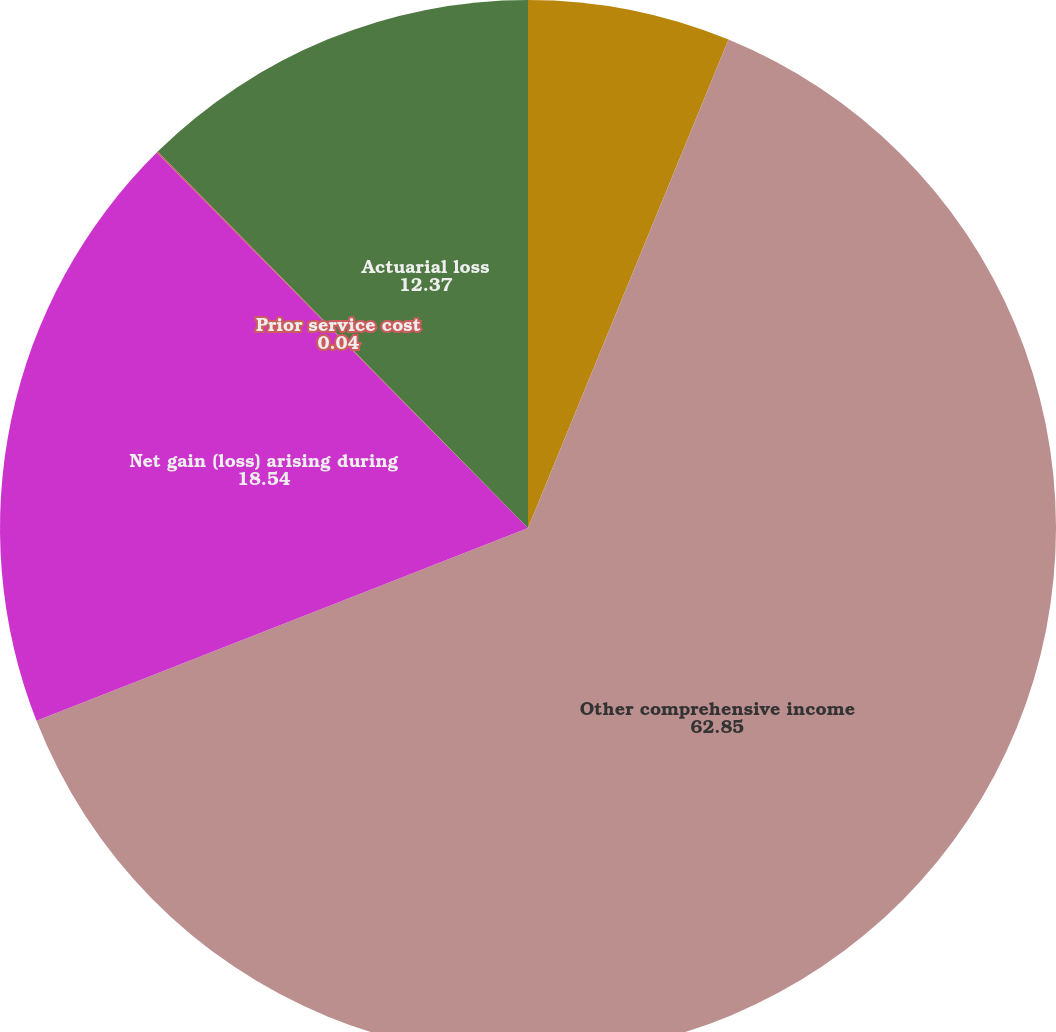Convert chart. <chart><loc_0><loc_0><loc_500><loc_500><pie_chart><fcel>(Dollars in thousands)<fcel>Other comprehensive income<fcel>Net gain (loss) arising during<fcel>Prior service cost<fcel>Actuarial loss<nl><fcel>6.2%<fcel>62.85%<fcel>18.54%<fcel>0.04%<fcel>12.37%<nl></chart> 